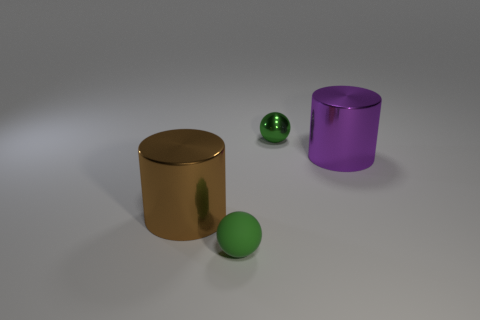Add 4 tiny shiny spheres. How many objects exist? 8 Subtract 2 cylinders. How many cylinders are left? 0 Subtract 0 red cylinders. How many objects are left? 4 Subtract all red balls. Subtract all yellow cubes. How many balls are left? 2 Subtract all cyan blocks. How many purple cylinders are left? 1 Subtract all blue metal cylinders. Subtract all balls. How many objects are left? 2 Add 1 big purple cylinders. How many big purple cylinders are left? 2 Add 3 cylinders. How many cylinders exist? 5 